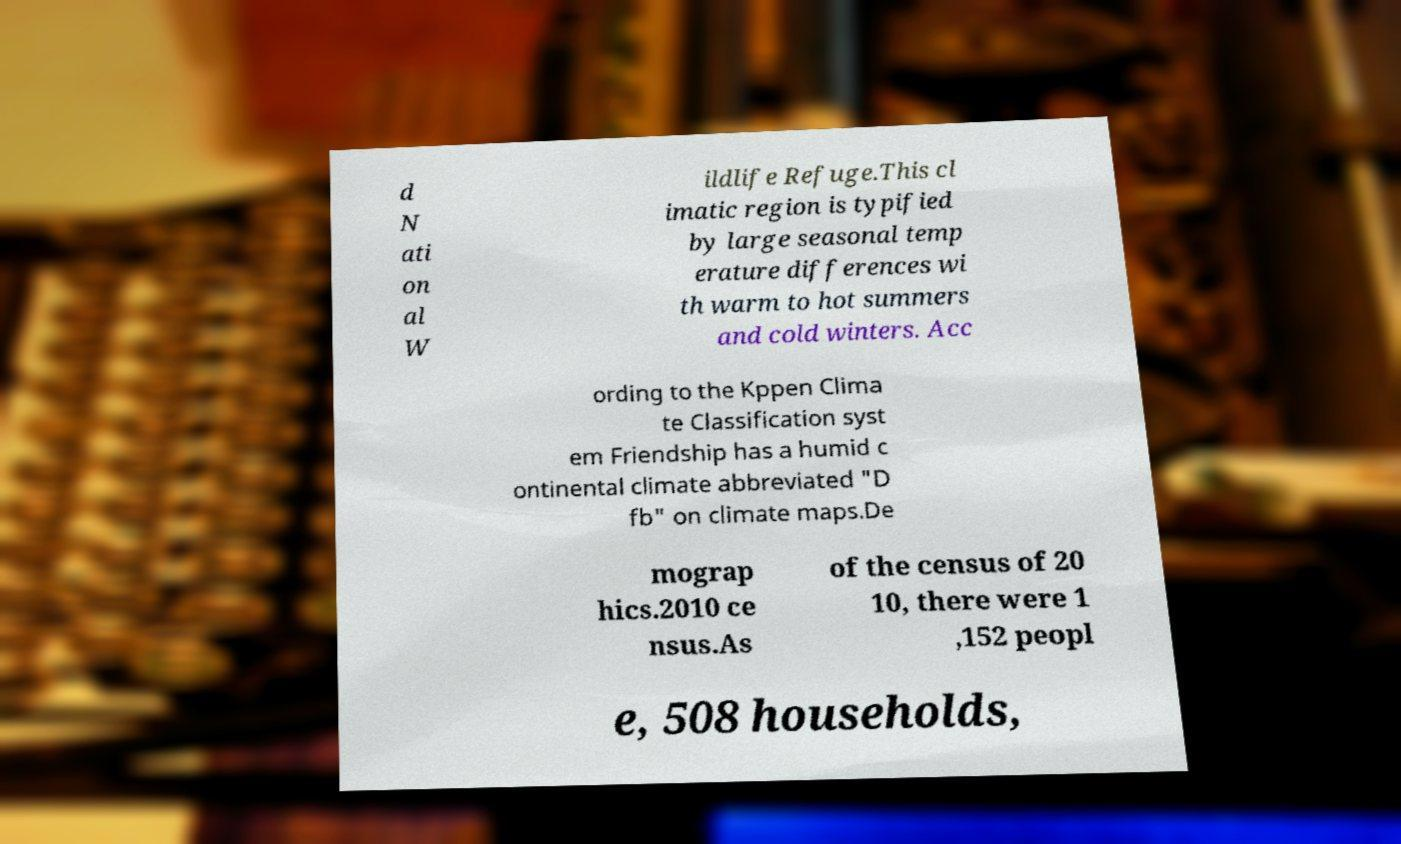Please identify and transcribe the text found in this image. d N ati on al W ildlife Refuge.This cl imatic region is typified by large seasonal temp erature differences wi th warm to hot summers and cold winters. Acc ording to the Kppen Clima te Classification syst em Friendship has a humid c ontinental climate abbreviated "D fb" on climate maps.De mograp hics.2010 ce nsus.As of the census of 20 10, there were 1 ,152 peopl e, 508 households, 